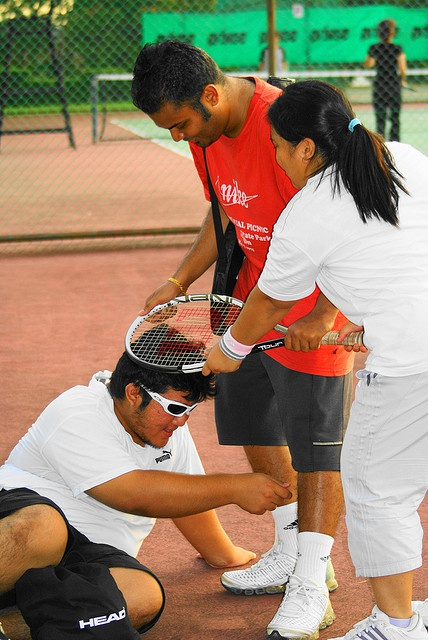Describe the objects in this image and their specific colors. I can see people in darkgreen, lightgray, black, brown, and tan tones, people in darkgreen, black, red, brown, and lightgray tones, people in darkgreen, lightgray, black, brown, and darkgray tones, tennis racket in darkgreen, black, tan, gray, and lightgray tones, and people in darkgreen, black, and gray tones in this image. 